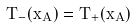<formula> <loc_0><loc_0><loc_500><loc_500>T _ { - } ( x _ { A } ) = T _ { + } ( x _ { A } )</formula> 